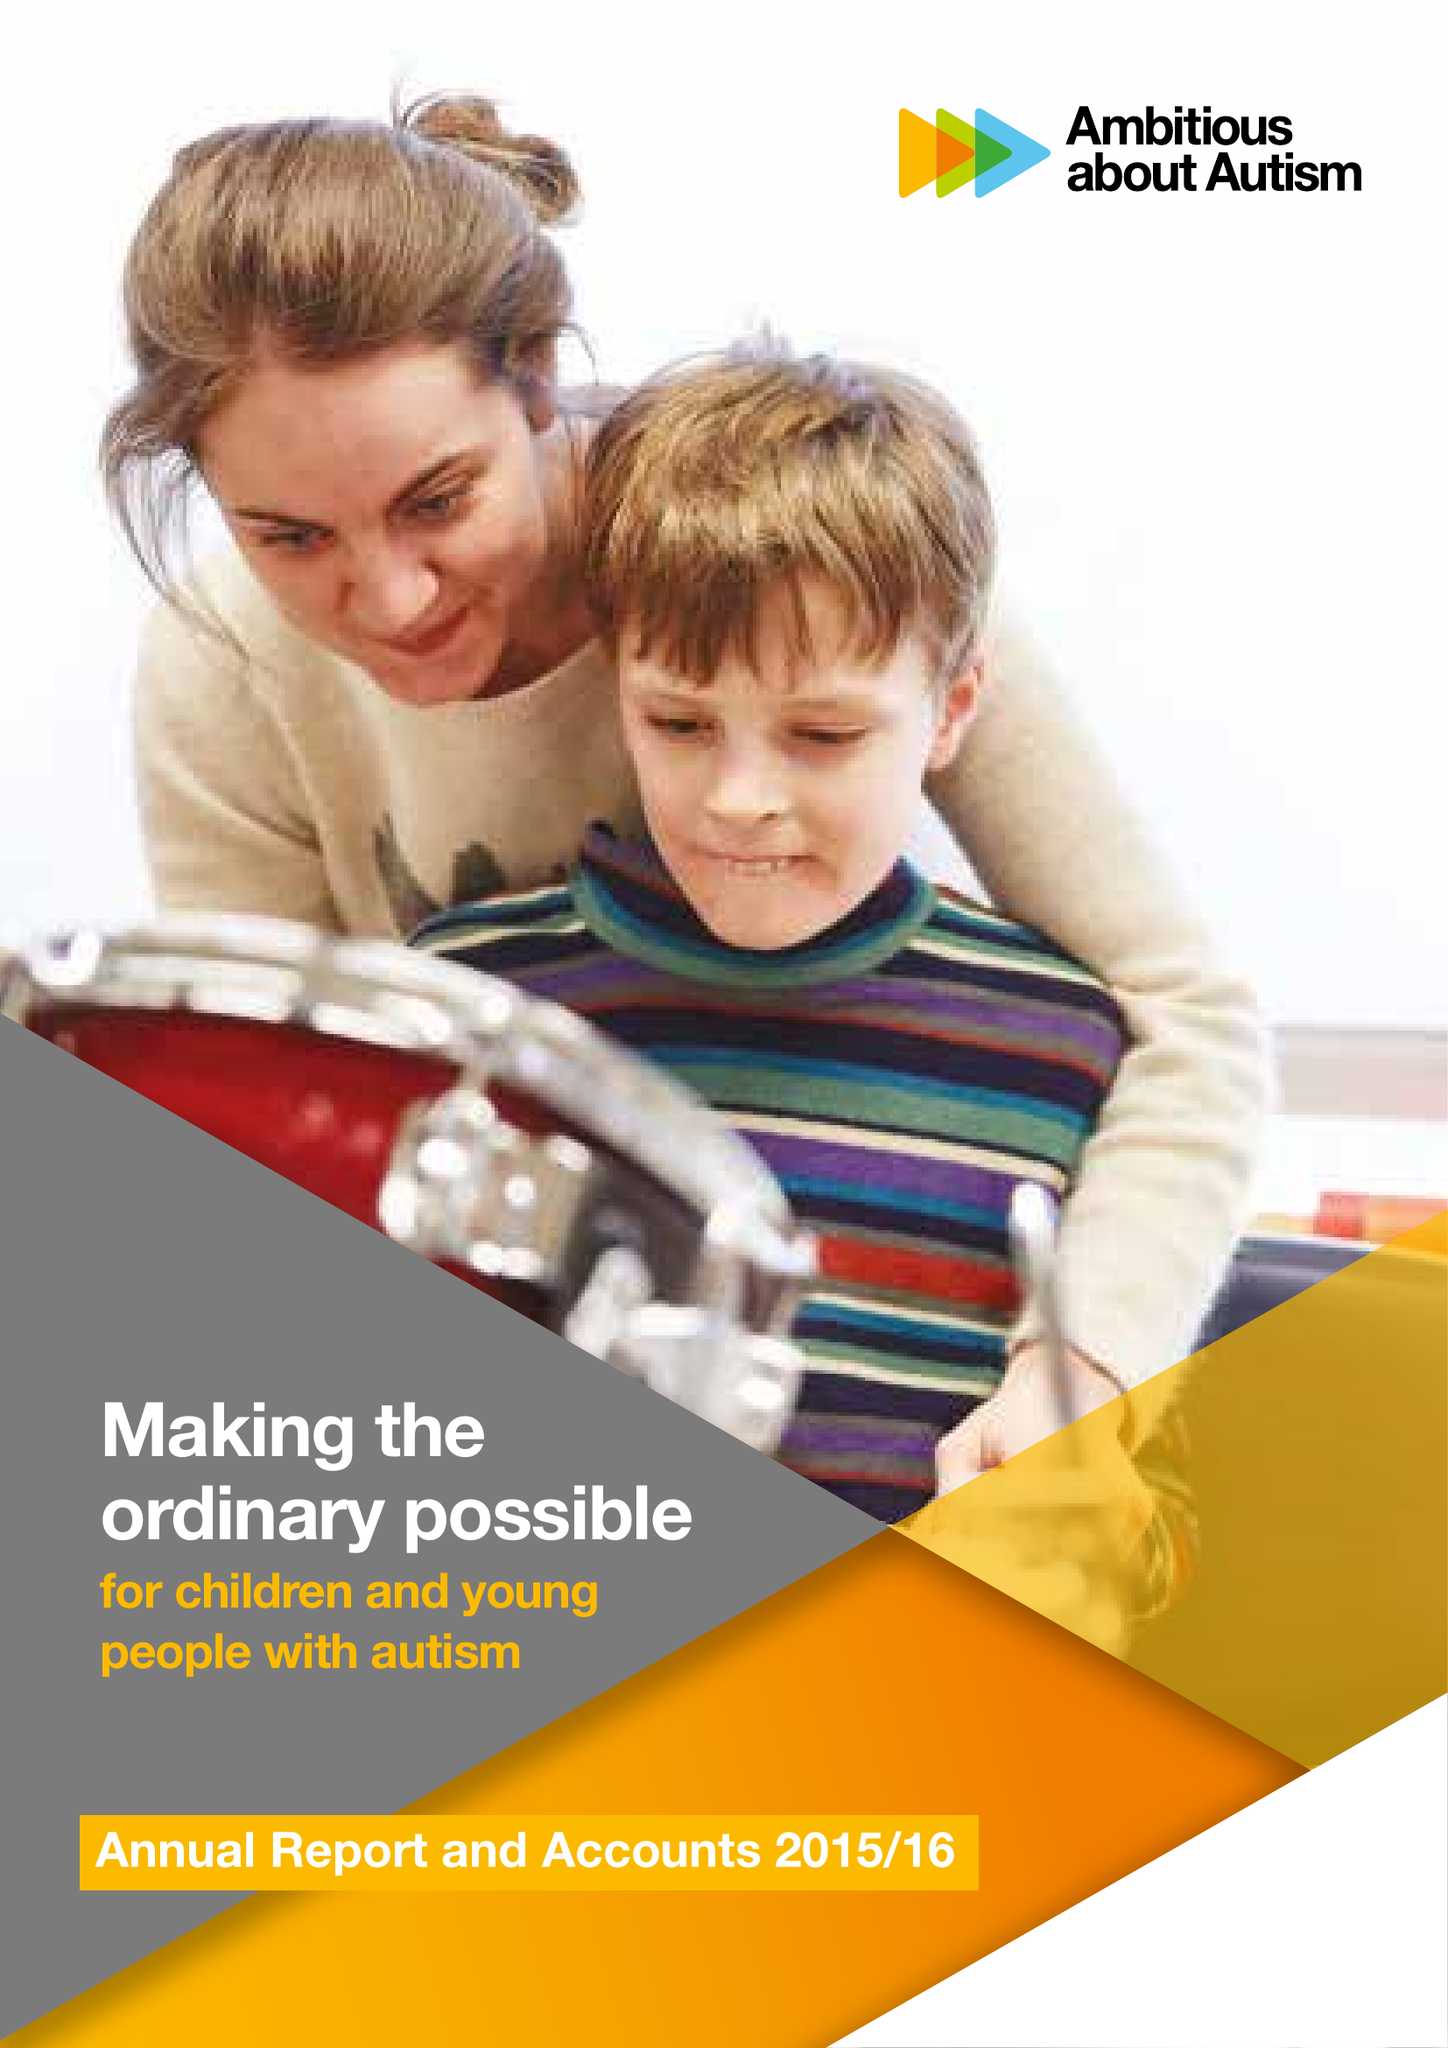What is the value for the address__post_town?
Answer the question using a single word or phrase. LONDON 